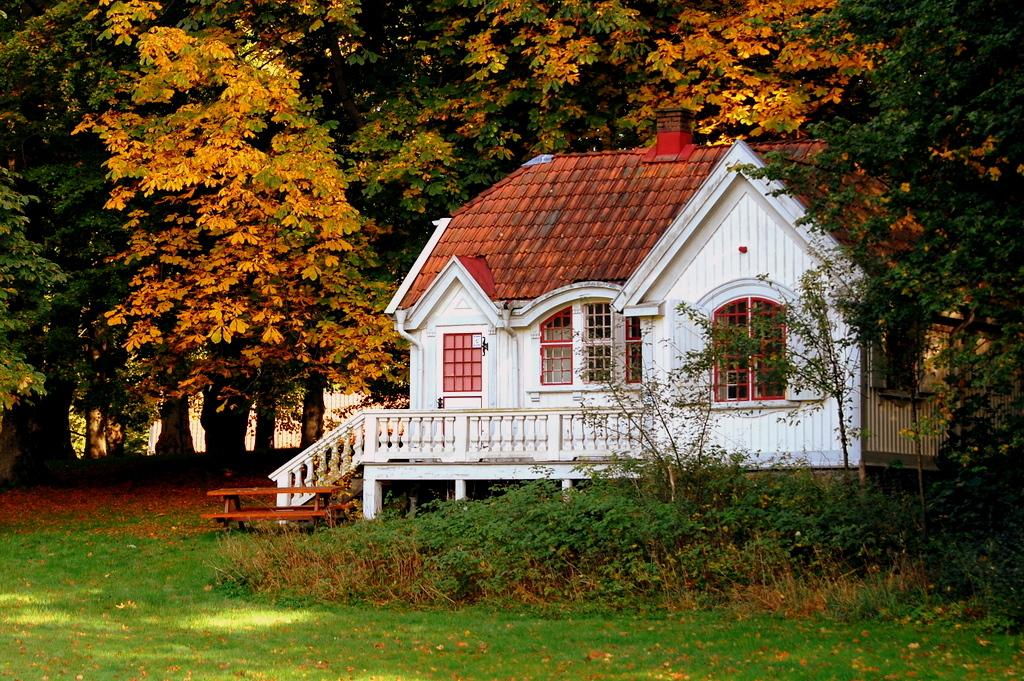What is the main structure in the center of the image? There is a shed in the center of the image. What can be used for sitting in the image? There is a bench in the image. What type of vegetation is present at the bottom of the image? Grass is present at the bottom of the image. What can be seen in the background of the image? There are trees and a fence in the background of the image. Is there a volcano erupting in the background of the image? No, there is no volcano present in the image. What type of dress is the person wearing in the image? There is no person or dress present in the image. 